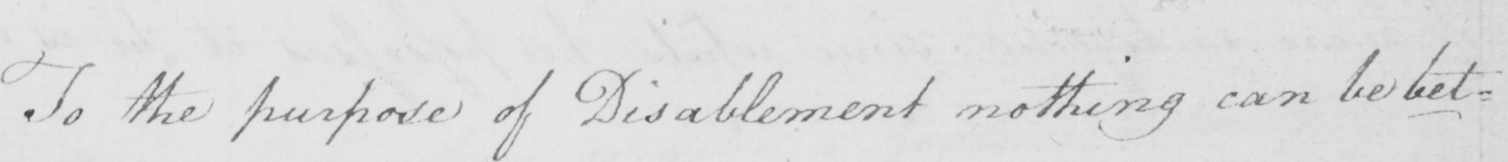Transcribe the text shown in this historical manuscript line. To the purpose of Disablement nothing can be bet= 